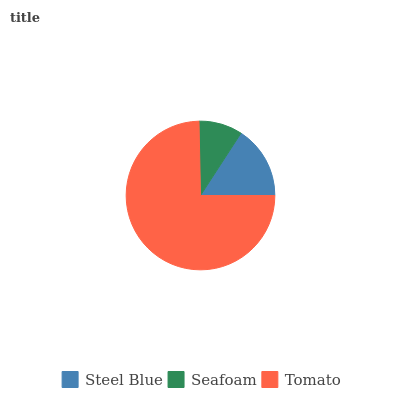Is Seafoam the minimum?
Answer yes or no. Yes. Is Tomato the maximum?
Answer yes or no. Yes. Is Tomato the minimum?
Answer yes or no. No. Is Seafoam the maximum?
Answer yes or no. No. Is Tomato greater than Seafoam?
Answer yes or no. Yes. Is Seafoam less than Tomato?
Answer yes or no. Yes. Is Seafoam greater than Tomato?
Answer yes or no. No. Is Tomato less than Seafoam?
Answer yes or no. No. Is Steel Blue the high median?
Answer yes or no. Yes. Is Steel Blue the low median?
Answer yes or no. Yes. Is Tomato the high median?
Answer yes or no. No. Is Tomato the low median?
Answer yes or no. No. 